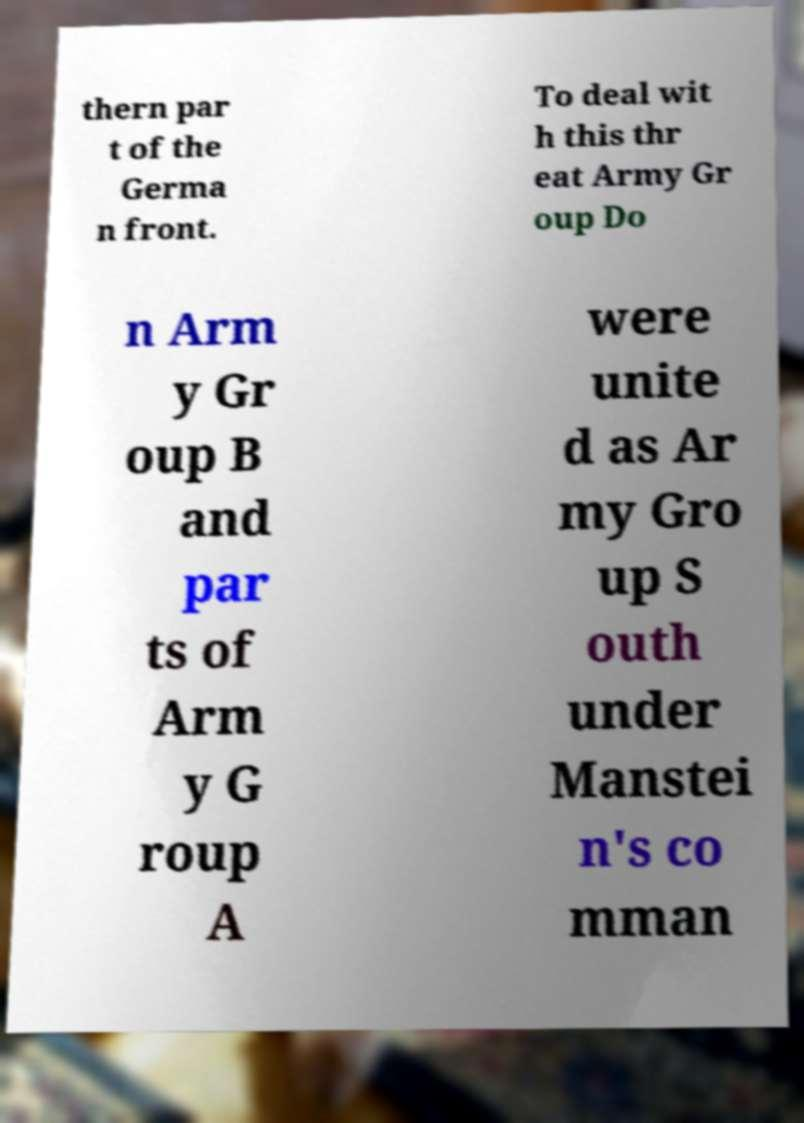Can you read and provide the text displayed in the image?This photo seems to have some interesting text. Can you extract and type it out for me? thern par t of the Germa n front. To deal wit h this thr eat Army Gr oup Do n Arm y Gr oup B and par ts of Arm y G roup A were unite d as Ar my Gro up S outh under Manstei n's co mman 